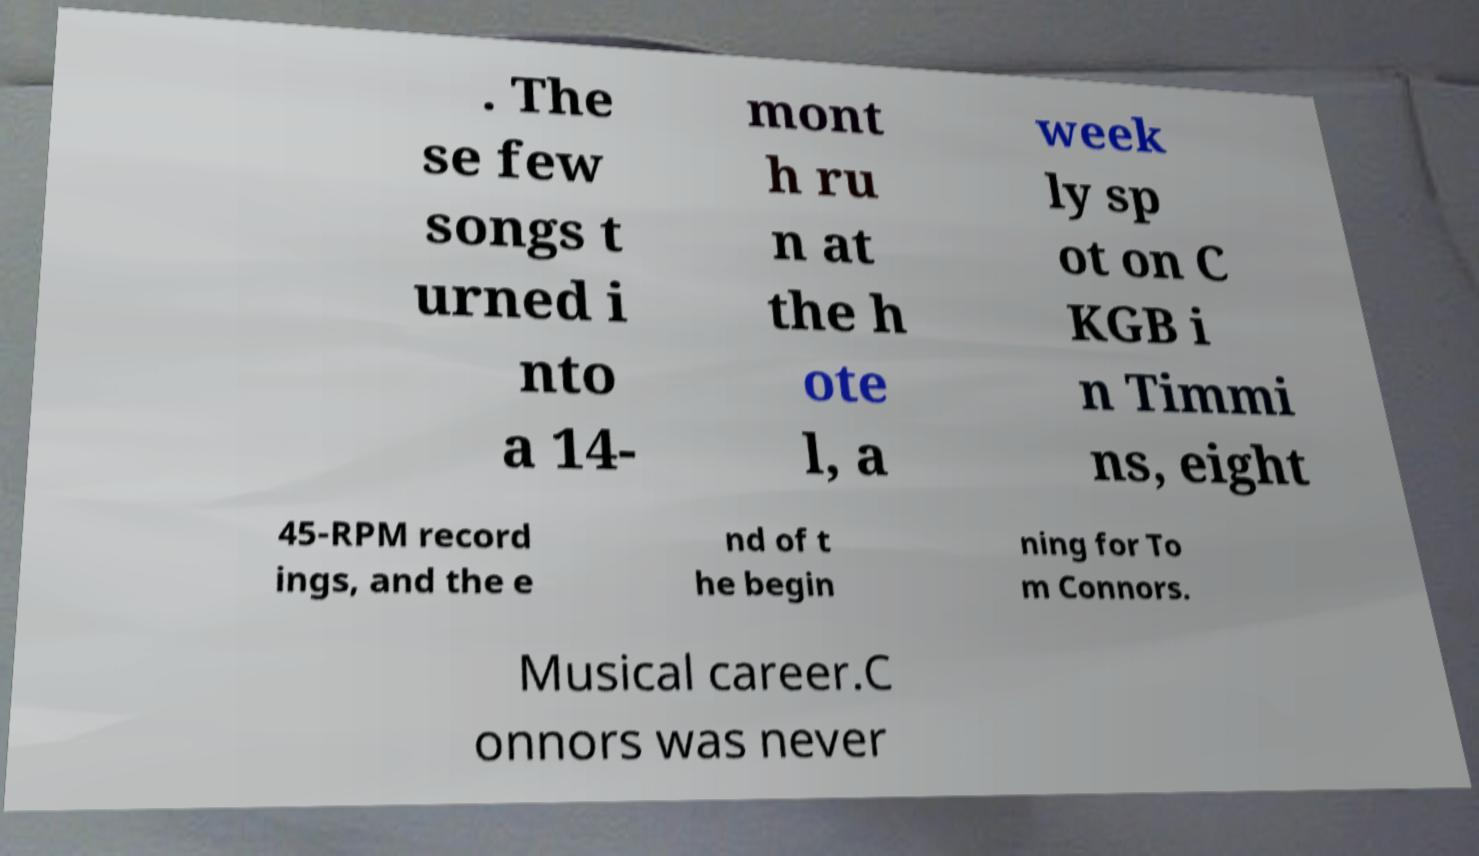For documentation purposes, I need the text within this image transcribed. Could you provide that? . The se few songs t urned i nto a 14- mont h ru n at the h ote l, a week ly sp ot on C KGB i n Timmi ns, eight 45-RPM record ings, and the e nd of t he begin ning for To m Connors. Musical career.C onnors was never 